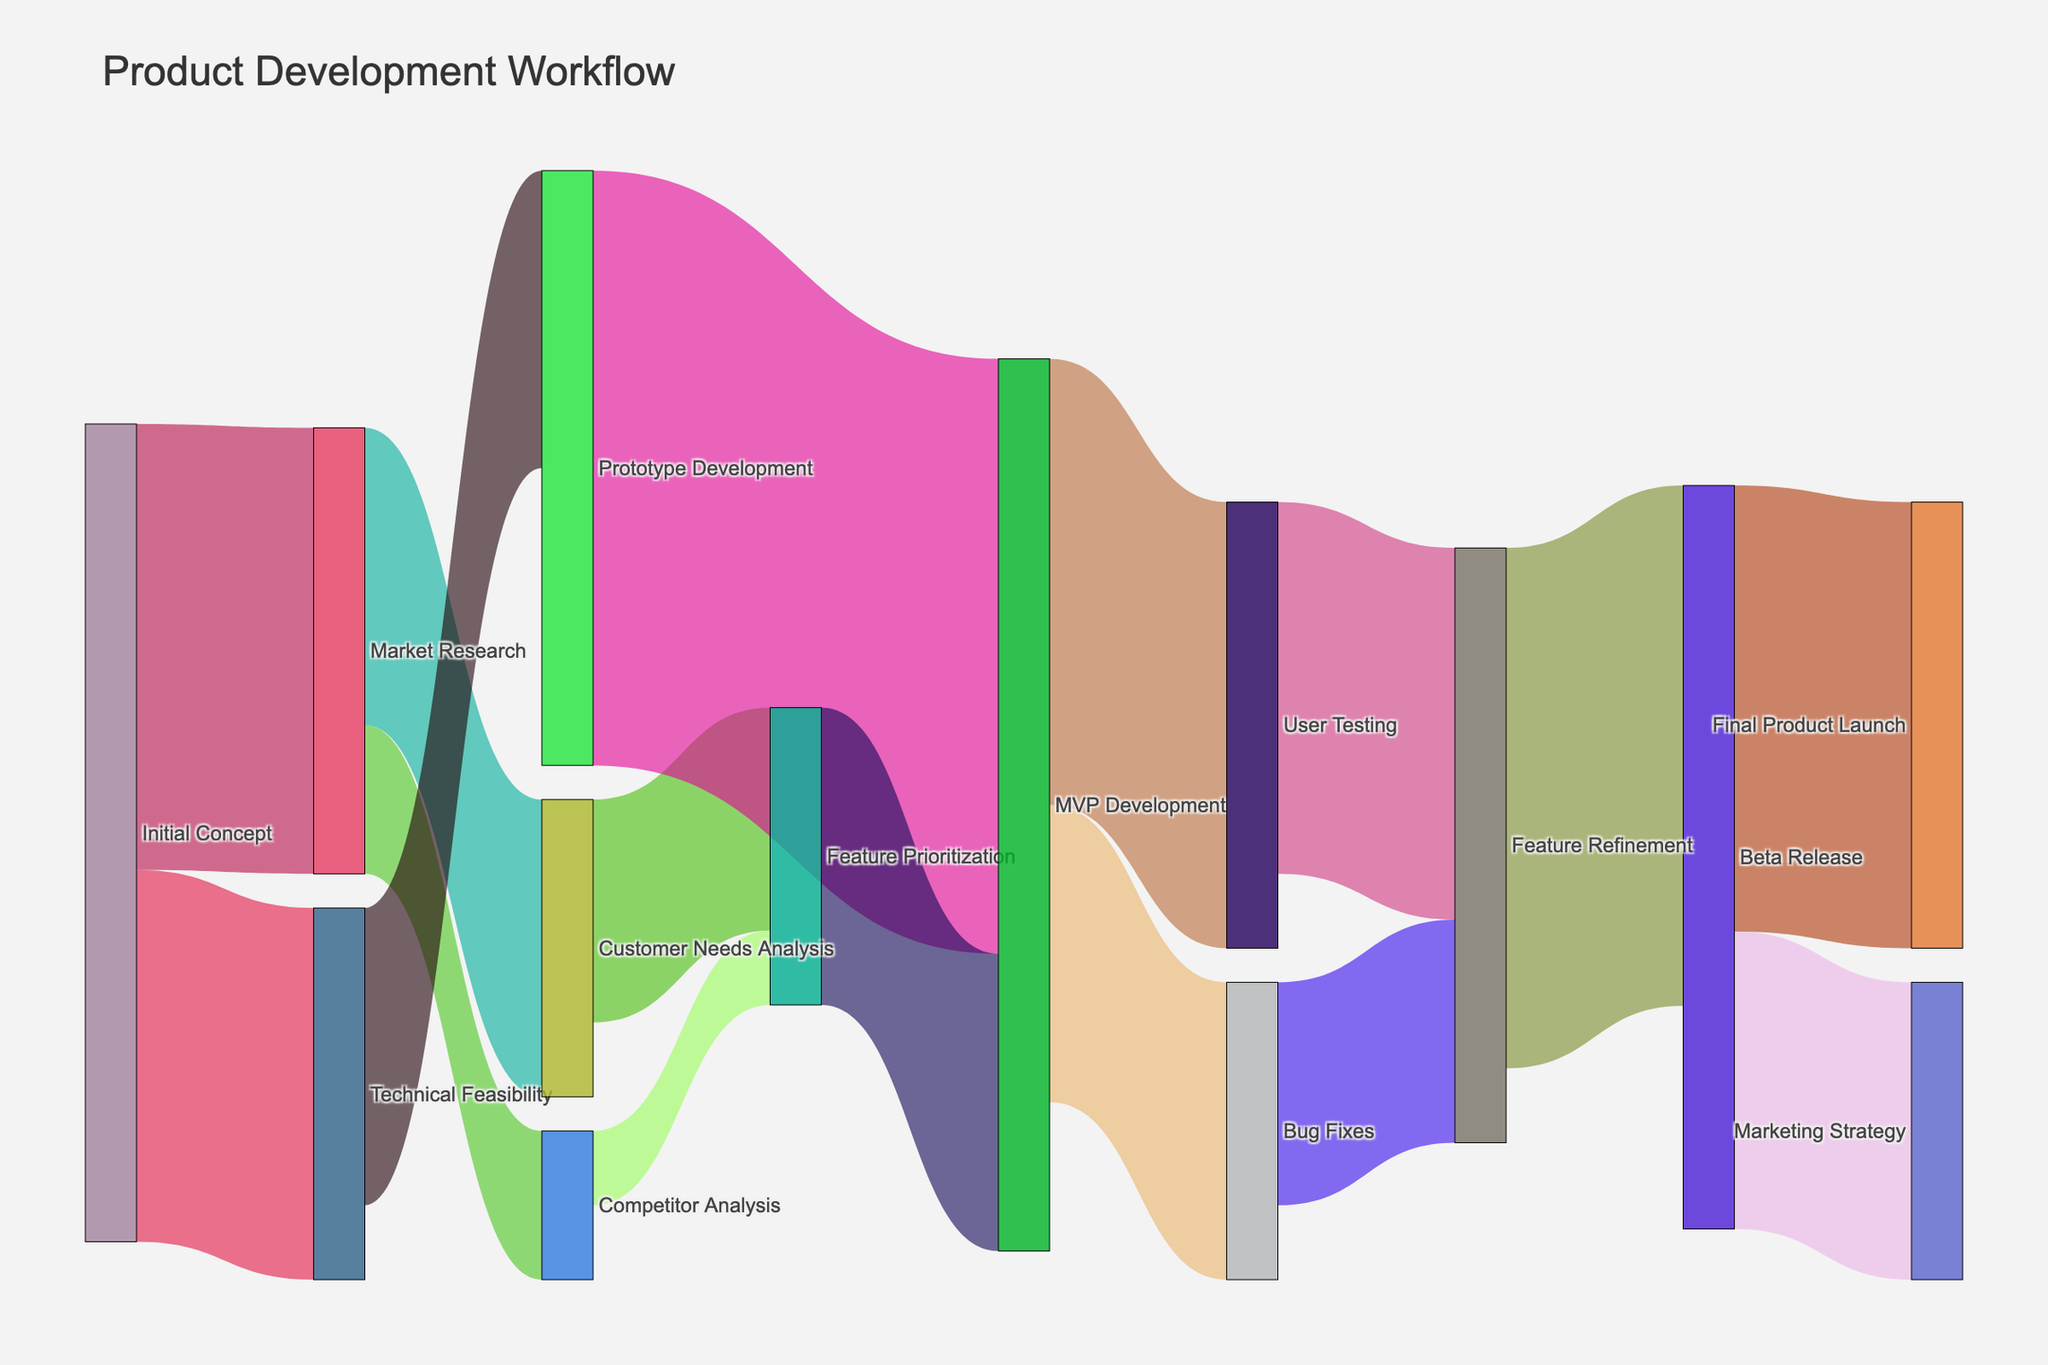What's the title of the figure? The title is displayed at the top of the figure and helps identify the main topic or theme represented in the Sankey Diagram. The title is "Product Development Workflow" as shown clearly at the top of the figure.
Answer: Product Development Workflow How many phases does the Initial Concept phase split into? By observing the figure, we can see that the Initial Concept splits into two different phases: Market Research and Technical Feasibility.
Answer: 2 Which phase has the highest value flowing to the Prototype Development? To determine this, look for flows directed to Prototype Development and compare their values. The highest value flow comes from Technical Feasibility with a value of 20.
Answer: Technical Feasibility What is the total value flowing out of the MVP Development phase? Total value is found by summing the values of all outgoing flows from MVP Development. These flows go to User Testing (30) and Bug Fixes (20). So, the total is 30 + 20 = 50.
Answer: 50 Which two phases contribute to the Feature Refinement phase? To find this, look for connections leading to Feature Refinement. The inputs come from User Testing (25) and Bug Fixes (15).
Answer: User Testing and Bug Fixes Compare the values from Market Research to its subsequent phases. Which has the higher value, Customer Needs Analysis or Competitor Analysis? Looking at the outgoing flows from Market Research, we see Customer Needs Analysis has a value of 20 and Competitor Analysis has a value of 10. 20 is higher than 10.
Answer: Customer Needs Analysis What's the combined value entering the MVP Development phase? The MVP Development phase has incoming flows from Prototype Development (40) and Feature Prioritization (20). Adding these values gives 40 + 20 = 60.
Answer: 60 Which phase receives more resources, Final Product Launch or Marketing Strategy? Resources to these phases are found by looking at the incoming flows. Final Product Launch receives 30 and Marketing Strategy receives 20. 30 is greater than 20.
Answer: Final Product Launch How does the value flowing from Feature Refinement to Final Product Launch compare to the value flowing to Marketing Strategy? The flow to Final Product Launch is 30 and to Marketing Strategy is 20. 30 is greater than 20.
Answer: Higher What's the sum of values that flow out of Market Research? Outflows from Market Research go to Customer Needs Analysis (20) and Competitor Analysis (10). The total is 20 + 10 = 30.
Answer: 30 